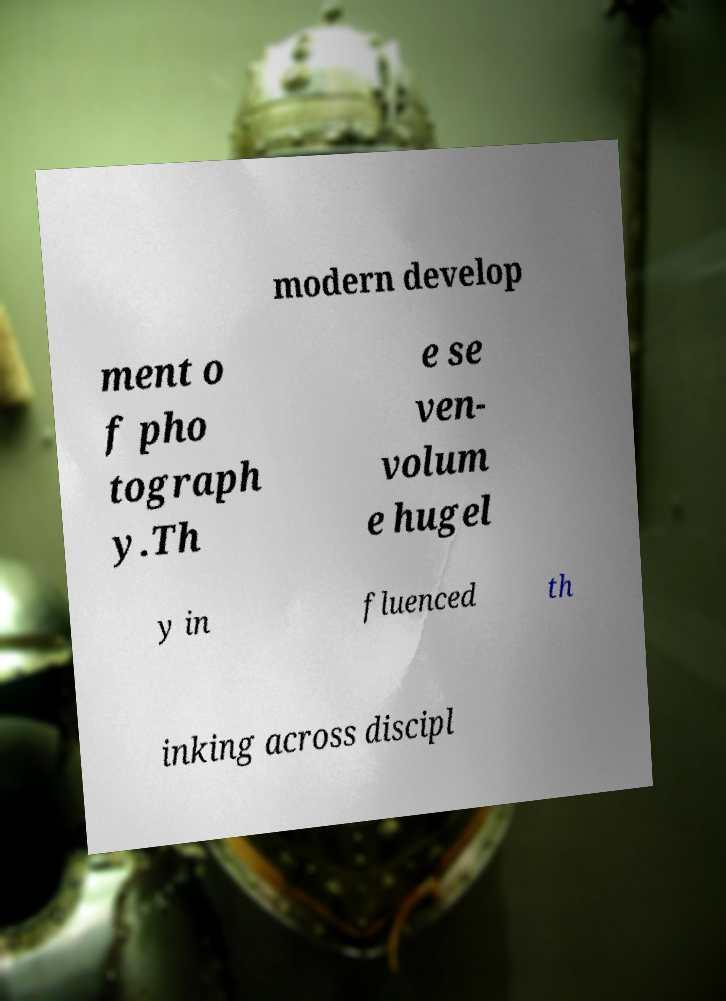Could you extract and type out the text from this image? modern develop ment o f pho tograph y.Th e se ven- volum e hugel y in fluenced th inking across discipl 